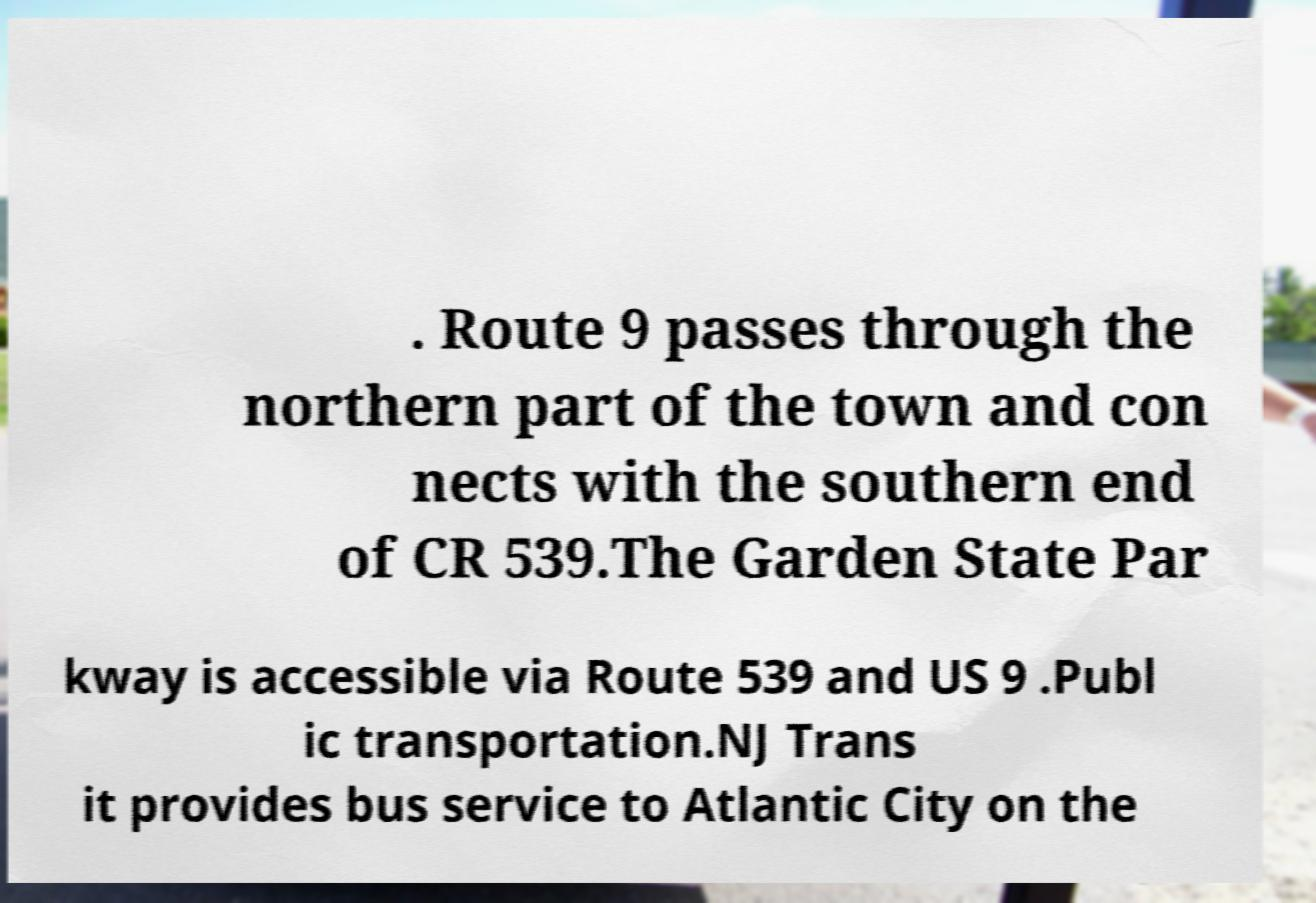I need the written content from this picture converted into text. Can you do that? . Route 9 passes through the northern part of the town and con nects with the southern end of CR 539.The Garden State Par kway is accessible via Route 539 and US 9 .Publ ic transportation.NJ Trans it provides bus service to Atlantic City on the 